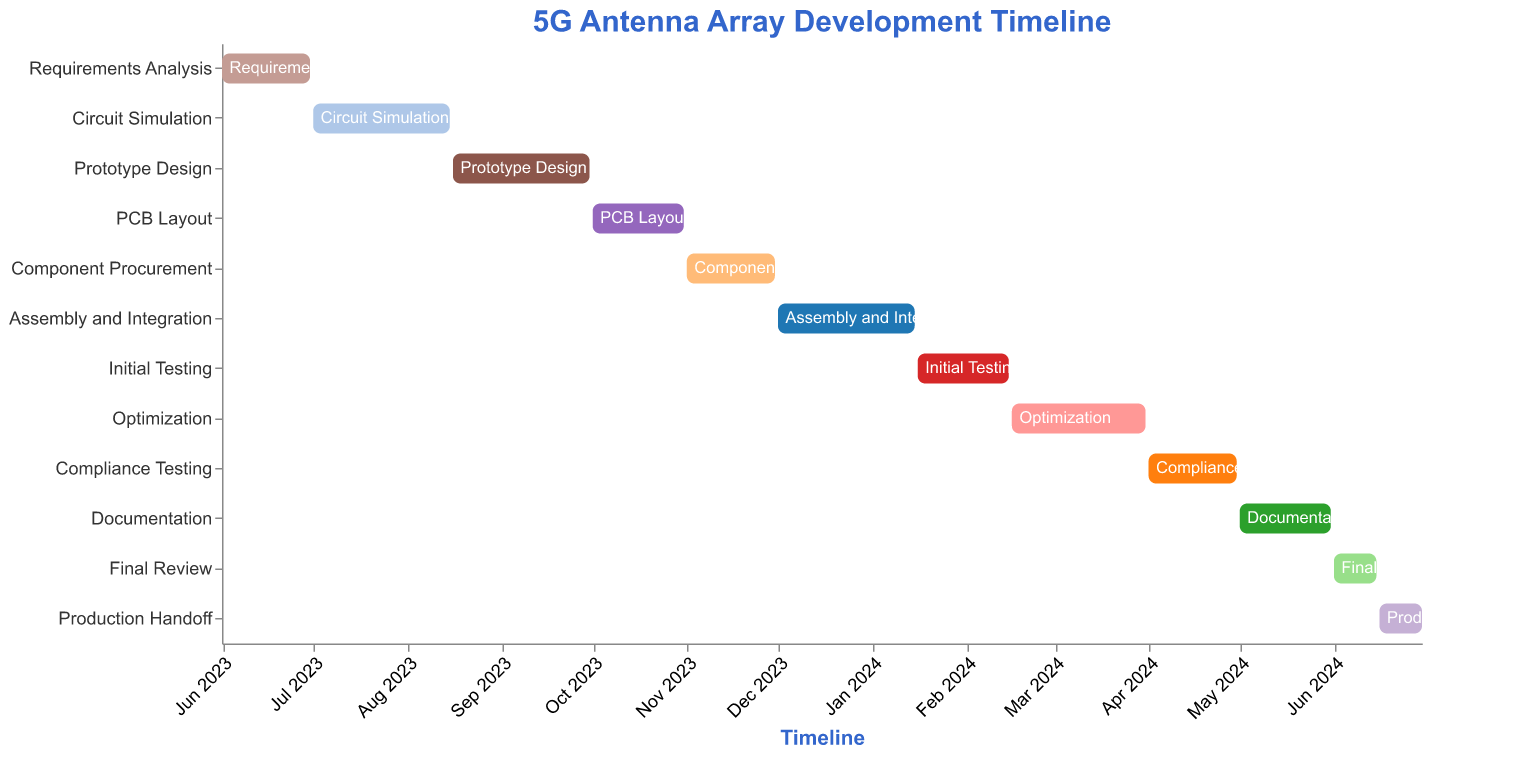What is the title of the Gantt Chart? The title is located at the top of the chart, typically featuring larger text or a different color to stand out. From the given code, the title is specified in the `title` field.
Answer: 5G Antenna Array Development Timeline What are the start and end dates for the "Requirements Analysis"? The start and end dates for each task are indicated on the Gantt chart. For "Requirements Analysis," these dates are mentioned at the beginning of the chart.
Answer: June 01, 2023 - June 30, 2023 Which task takes the least amount of time? To find the task that takes the least amount of time, calculate the duration for each task by subtracting the start date from the end date. "Final Review" takes the fewest days (15 days).
Answer: Final Review Which task has the same start and end month? Look for tasks that start and end within the same month. For example, "PCB Layout" starts on October 1, 2023, and ends on October 31, 2023.
Answer: PCB Layout How long is the "Assembly and Integration" phase? Calculate the duration by subtracting the start date from the end date. "Assembly and Integration" goes from December 1, 2023, to January 15, 2024, lasting 46 days.
Answer: 46 days Sum the total duration of "Initial Testing" and "Optimization"? Calculate each task’s duration. "Initial Testing" is from January 16, 2024, to February 15, 2024 (31 days), and "Optimization" is from February 16, 2024, to March 31, 2024 (45 days). Summed up, it's 31+45.
Answer: 76 days Which tasks overlap with the "Optimization" phase? To determine which tasks overlap, check their start and end dates relative to "Optimization" (February 16, 2024, to March 31, 2024). "Initial Testing" overlaps slightly as it ends on February 15, 2024.
Answer: None Is "Compliance Testing" shorter than "Documentation"? Compare both tasks’ durations. "Compliance Testing" (April 1, 2024, to April 30, 2024) is 30 days. "Documentation" (May 1, 2024, to May 31, 2024) is also 31 days.
Answer: Yes What is the final task before production handoff? Identify the task immediately preceding "Production Handoff" by the timeline sequence. "Final Review" ends on June 15, 2024, right before "Production Handoff" starts on June 16, 2024.
Answer: Final Review What is the total duration of the project from "Requirements Analysis" to "Production Handoff"? Calculate the overall duration by subtracting the start date of the first task from the end date of the last task. The project starts on June 1, 2023, and ends on June 30, 2024, totaling 395 days.
Answer: 395 days 